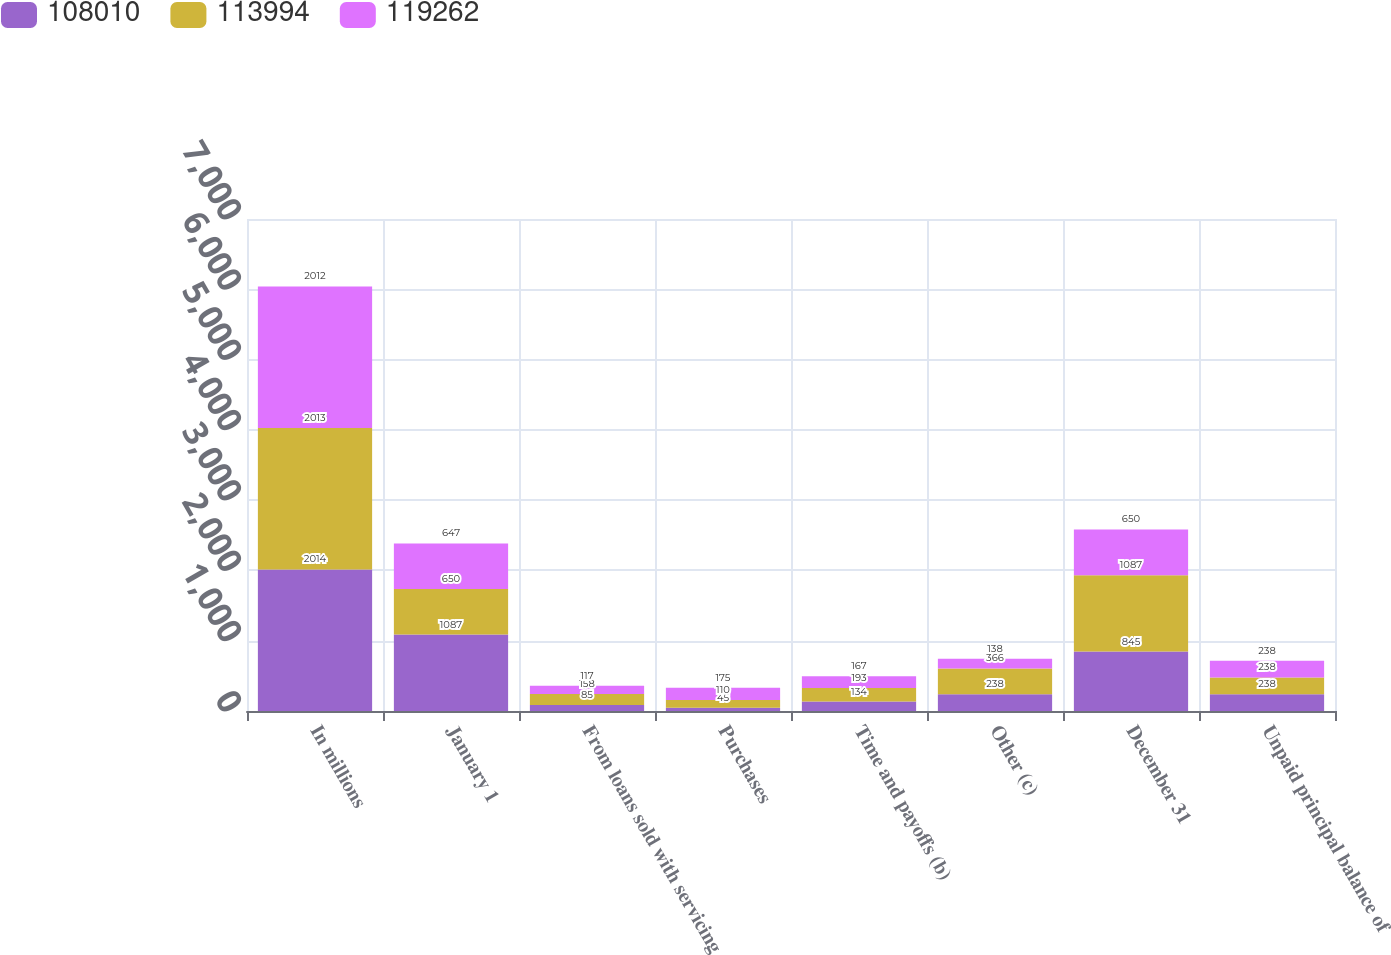Convert chart. <chart><loc_0><loc_0><loc_500><loc_500><stacked_bar_chart><ecel><fcel>In millions<fcel>January 1<fcel>From loans sold with servicing<fcel>Purchases<fcel>Time and payoffs (b)<fcel>Other (c)<fcel>December 31<fcel>Unpaid principal balance of<nl><fcel>108010<fcel>2014<fcel>1087<fcel>85<fcel>45<fcel>134<fcel>238<fcel>845<fcel>238<nl><fcel>113994<fcel>2013<fcel>650<fcel>158<fcel>110<fcel>193<fcel>366<fcel>1087<fcel>238<nl><fcel>119262<fcel>2012<fcel>647<fcel>117<fcel>175<fcel>167<fcel>138<fcel>650<fcel>238<nl></chart> 